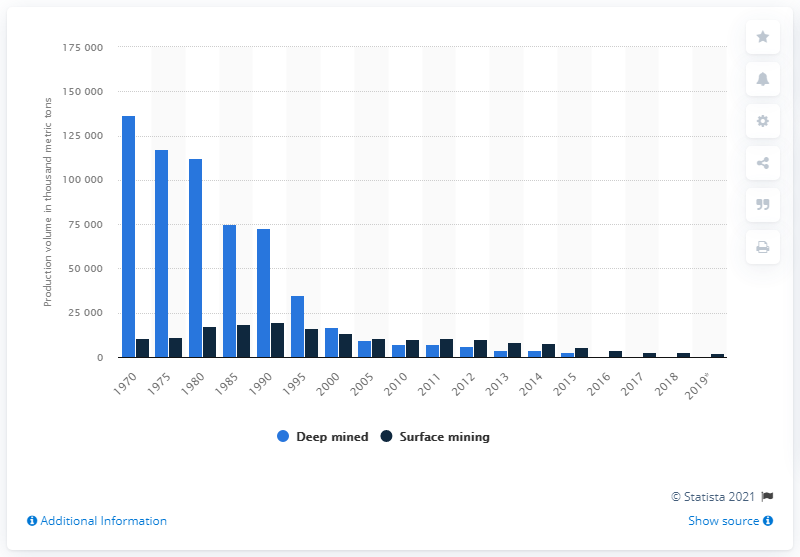Identify some key points in this picture. Since 1970, the volume of coal produced has fallen. In 2005, surface mining surpassed deep mining as the most productive mining method. 